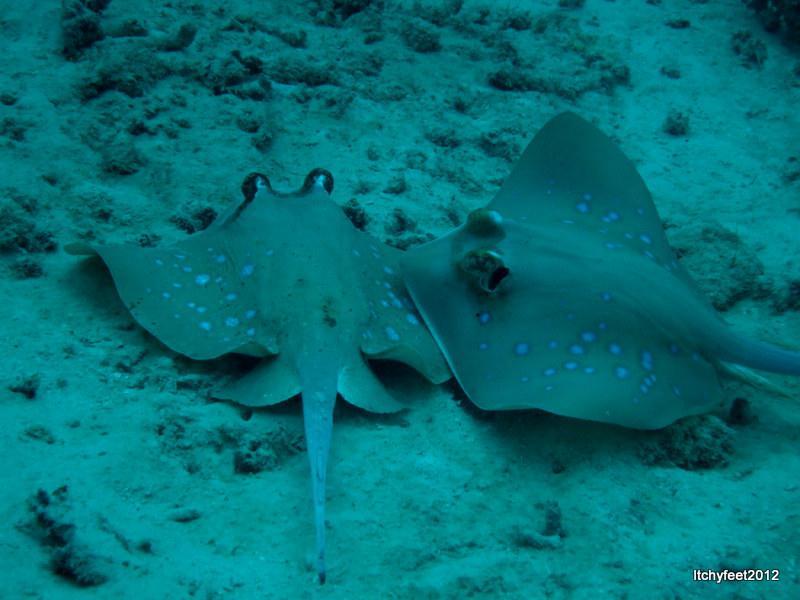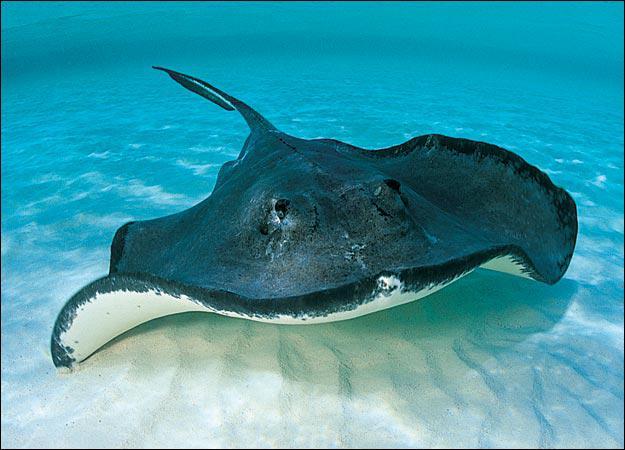The first image is the image on the left, the second image is the image on the right. For the images displayed, is the sentence "All of the stingrays are laying on the ocean floor." factually correct? Answer yes or no. No. 